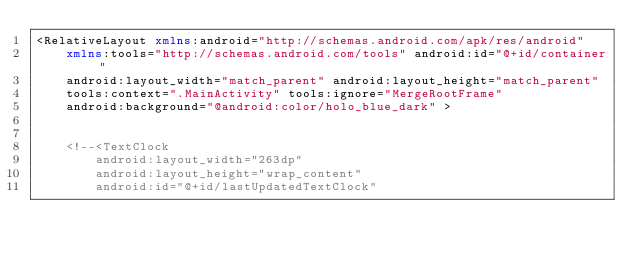<code> <loc_0><loc_0><loc_500><loc_500><_XML_><RelativeLayout xmlns:android="http://schemas.android.com/apk/res/android"
    xmlns:tools="http://schemas.android.com/tools" android:id="@+id/container"
    android:layout_width="match_parent" android:layout_height="match_parent"
    tools:context=".MainActivity" tools:ignore="MergeRootFrame"
    android:background="@android:color/holo_blue_dark" >


    <!--<TextClock
        android:layout_width="263dp"
        android:layout_height="wrap_content"
        android:id="@+id/lastUpdatedTextClock"</code> 